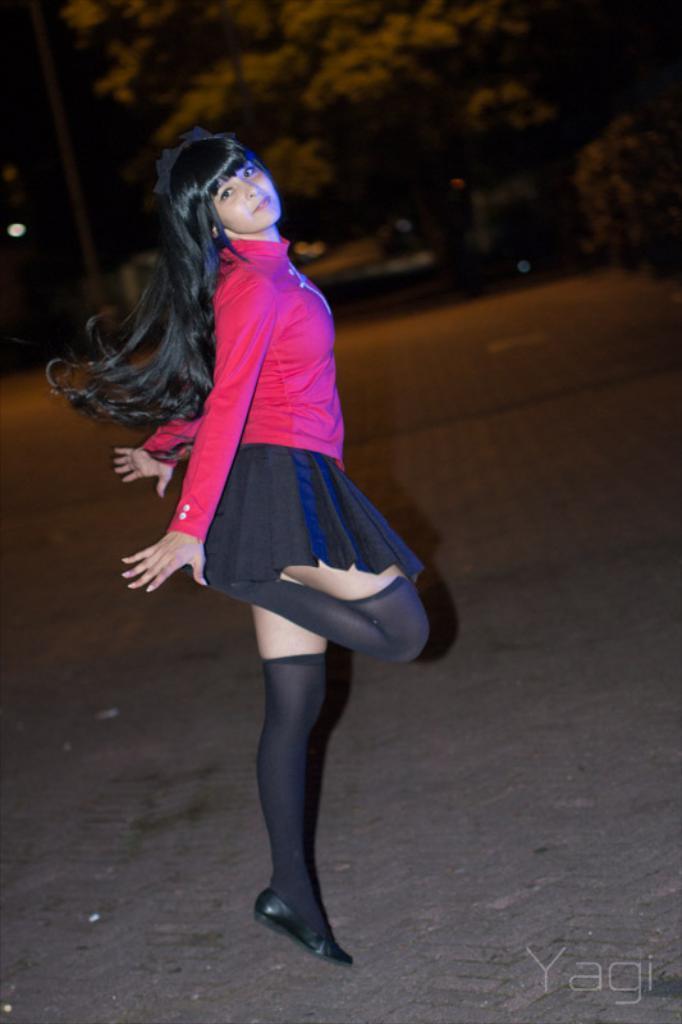Could you give a brief overview of what you see in this image? In this image we can see a woman with long hair wearing pink shirt is standing on the ground. In the background, we can see a group of trees. 